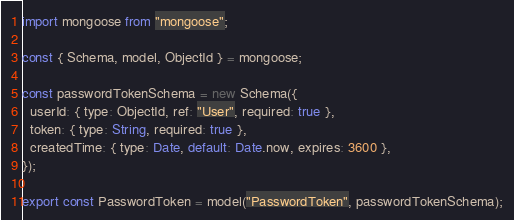<code> <loc_0><loc_0><loc_500><loc_500><_JavaScript_>import mongoose from "mongoose";

const { Schema, model, ObjectId } = mongoose;

const passwordTokenSchema = new Schema({
  userId: { type: ObjectId, ref: "User", required: true },
  token: { type: String, required: true },
  createdTime: { type: Date, default: Date.now, expires: 3600 },
});

export const PasswordToken = model("PasswordToken", passwordTokenSchema);


</code> 